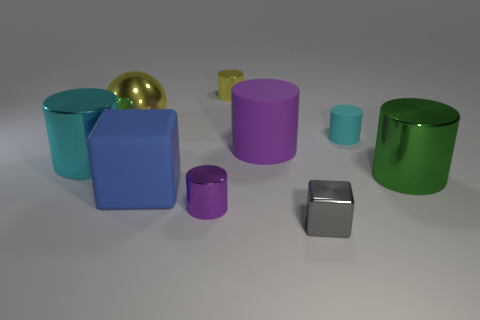Are there more green cylinders than yellow things?
Your answer should be very brief. No. Is the small cylinder in front of the big green shiny object made of the same material as the cyan thing left of the large yellow metallic thing?
Provide a short and direct response. Yes. What is the material of the green object?
Your response must be concise. Metal. Is the number of big metal cylinders on the right side of the big yellow shiny sphere greater than the number of large green rubber spheres?
Make the answer very short. Yes. There is a tiny cylinder right of the cube on the right side of the tiny yellow object; how many large yellow shiny spheres are in front of it?
Provide a succinct answer. 0. There is a object that is both behind the purple rubber thing and to the right of the gray object; what material is it?
Your answer should be compact. Rubber. What color is the metallic cube?
Keep it short and to the point. Gray. Are there more small rubber cylinders that are to the left of the purple shiny object than cyan cylinders in front of the large cyan object?
Provide a succinct answer. No. The cylinder in front of the large blue object is what color?
Ensure brevity in your answer.  Purple. Does the cyan thing that is on the left side of the large matte cylinder have the same size as the metal cylinder that is behind the tiny cyan matte thing?
Offer a terse response. No. 